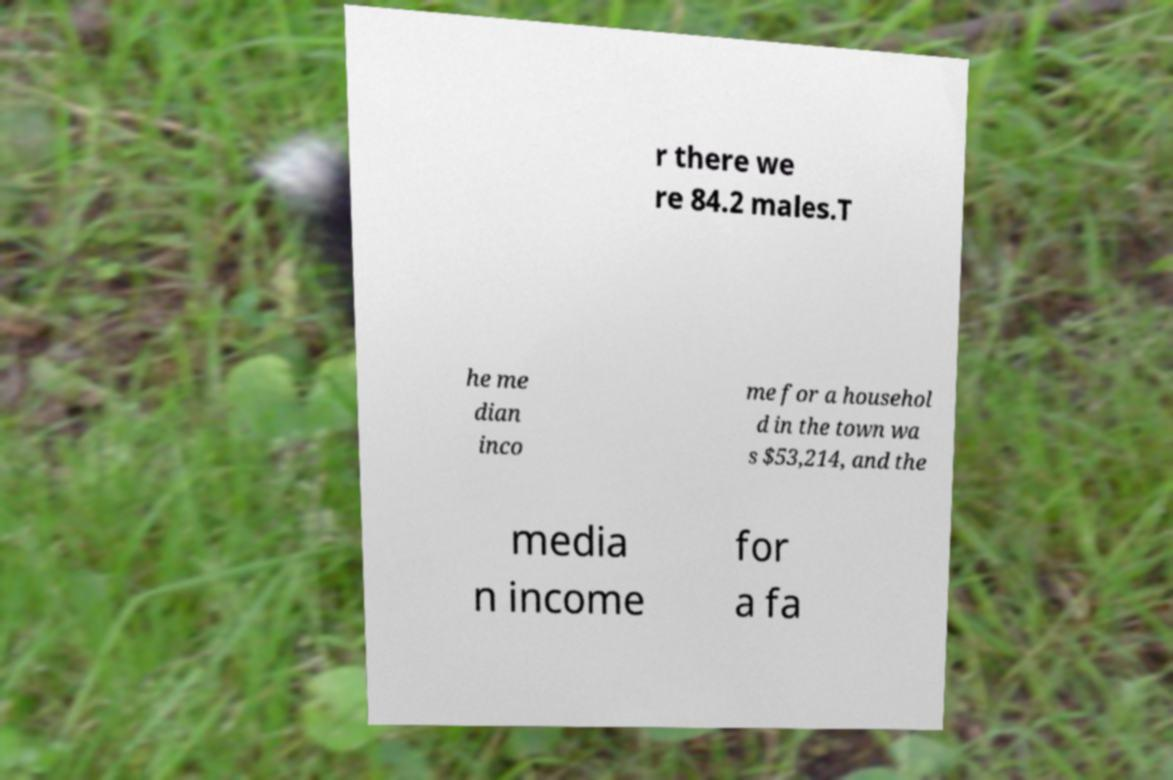For documentation purposes, I need the text within this image transcribed. Could you provide that? r there we re 84.2 males.T he me dian inco me for a househol d in the town wa s $53,214, and the media n income for a fa 